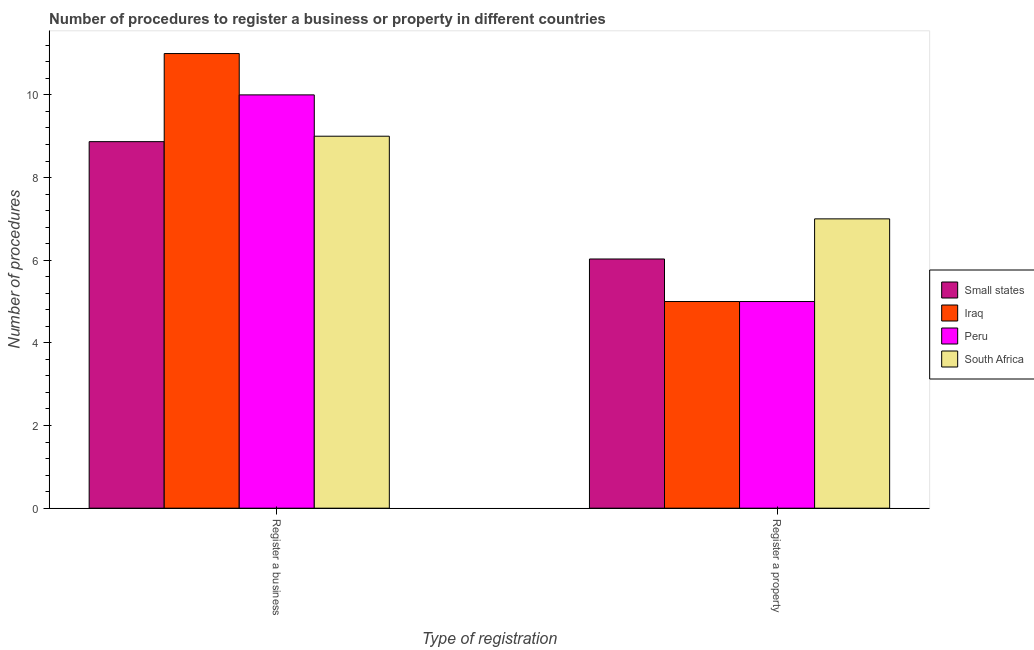How many different coloured bars are there?
Your answer should be compact. 4. How many groups of bars are there?
Ensure brevity in your answer.  2. Are the number of bars per tick equal to the number of legend labels?
Offer a terse response. Yes. Are the number of bars on each tick of the X-axis equal?
Keep it short and to the point. Yes. How many bars are there on the 2nd tick from the right?
Offer a terse response. 4. What is the label of the 1st group of bars from the left?
Make the answer very short. Register a business. What is the number of procedures to register a business in Small states?
Provide a succinct answer. 8.87. In which country was the number of procedures to register a business maximum?
Ensure brevity in your answer.  Iraq. In which country was the number of procedures to register a property minimum?
Give a very brief answer. Iraq. What is the total number of procedures to register a property in the graph?
Offer a very short reply. 23.03. What is the difference between the number of procedures to register a property in Small states and that in South Africa?
Your response must be concise. -0.97. What is the difference between the number of procedures to register a business in South Africa and the number of procedures to register a property in Small states?
Your answer should be compact. 2.97. What is the average number of procedures to register a business per country?
Make the answer very short. 9.72. What is the difference between the number of procedures to register a property and number of procedures to register a business in Small states?
Ensure brevity in your answer.  -2.84. What is the ratio of the number of procedures to register a property in Small states to that in Peru?
Provide a short and direct response. 1.21. What does the 3rd bar from the left in Register a business represents?
Provide a short and direct response. Peru. What does the 2nd bar from the right in Register a property represents?
Make the answer very short. Peru. How many bars are there?
Provide a succinct answer. 8. Are all the bars in the graph horizontal?
Your response must be concise. No. Are the values on the major ticks of Y-axis written in scientific E-notation?
Offer a very short reply. No. What is the title of the graph?
Provide a short and direct response. Number of procedures to register a business or property in different countries. Does "South Asia" appear as one of the legend labels in the graph?
Your answer should be compact. No. What is the label or title of the X-axis?
Give a very brief answer. Type of registration. What is the label or title of the Y-axis?
Your response must be concise. Number of procedures. What is the Number of procedures in Small states in Register a business?
Your answer should be compact. 8.87. What is the Number of procedures in Small states in Register a property?
Your response must be concise. 6.03. What is the Number of procedures in Peru in Register a property?
Provide a short and direct response. 5. What is the Number of procedures of South Africa in Register a property?
Your answer should be compact. 7. Across all Type of registration, what is the maximum Number of procedures in Small states?
Your answer should be very brief. 8.87. Across all Type of registration, what is the maximum Number of procedures of South Africa?
Provide a succinct answer. 9. Across all Type of registration, what is the minimum Number of procedures of Small states?
Provide a succinct answer. 6.03. Across all Type of registration, what is the minimum Number of procedures of Iraq?
Offer a very short reply. 5. Across all Type of registration, what is the minimum Number of procedures of South Africa?
Ensure brevity in your answer.  7. What is the total Number of procedures in Small states in the graph?
Keep it short and to the point. 14.9. What is the total Number of procedures of Peru in the graph?
Keep it short and to the point. 15. What is the difference between the Number of procedures of Small states in Register a business and that in Register a property?
Give a very brief answer. 2.84. What is the difference between the Number of procedures in Iraq in Register a business and that in Register a property?
Offer a terse response. 6. What is the difference between the Number of procedures in Small states in Register a business and the Number of procedures in Iraq in Register a property?
Ensure brevity in your answer.  3.87. What is the difference between the Number of procedures of Small states in Register a business and the Number of procedures of Peru in Register a property?
Provide a short and direct response. 3.87. What is the difference between the Number of procedures of Small states in Register a business and the Number of procedures of South Africa in Register a property?
Offer a very short reply. 1.87. What is the difference between the Number of procedures in Peru in Register a business and the Number of procedures in South Africa in Register a property?
Ensure brevity in your answer.  3. What is the average Number of procedures of Small states per Type of registration?
Your response must be concise. 7.45. What is the average Number of procedures in Iraq per Type of registration?
Offer a terse response. 8. What is the average Number of procedures of South Africa per Type of registration?
Provide a short and direct response. 8. What is the difference between the Number of procedures in Small states and Number of procedures in Iraq in Register a business?
Keep it short and to the point. -2.13. What is the difference between the Number of procedures in Small states and Number of procedures in Peru in Register a business?
Your answer should be very brief. -1.13. What is the difference between the Number of procedures of Small states and Number of procedures of South Africa in Register a business?
Offer a very short reply. -0.13. What is the difference between the Number of procedures in Iraq and Number of procedures in South Africa in Register a business?
Your response must be concise. 2. What is the difference between the Number of procedures in Small states and Number of procedures in Iraq in Register a property?
Provide a short and direct response. 1.03. What is the difference between the Number of procedures in Small states and Number of procedures in Peru in Register a property?
Your answer should be very brief. 1.03. What is the difference between the Number of procedures of Small states and Number of procedures of South Africa in Register a property?
Give a very brief answer. -0.97. What is the difference between the Number of procedures in Iraq and Number of procedures in Peru in Register a property?
Your answer should be compact. 0. What is the difference between the Number of procedures of Peru and Number of procedures of South Africa in Register a property?
Offer a very short reply. -2. What is the ratio of the Number of procedures in Small states in Register a business to that in Register a property?
Give a very brief answer. 1.47. What is the ratio of the Number of procedures of South Africa in Register a business to that in Register a property?
Your response must be concise. 1.29. What is the difference between the highest and the second highest Number of procedures of Small states?
Give a very brief answer. 2.84. What is the difference between the highest and the second highest Number of procedures of South Africa?
Provide a short and direct response. 2. What is the difference between the highest and the lowest Number of procedures in Small states?
Provide a short and direct response. 2.84. What is the difference between the highest and the lowest Number of procedures of Iraq?
Provide a succinct answer. 6. 